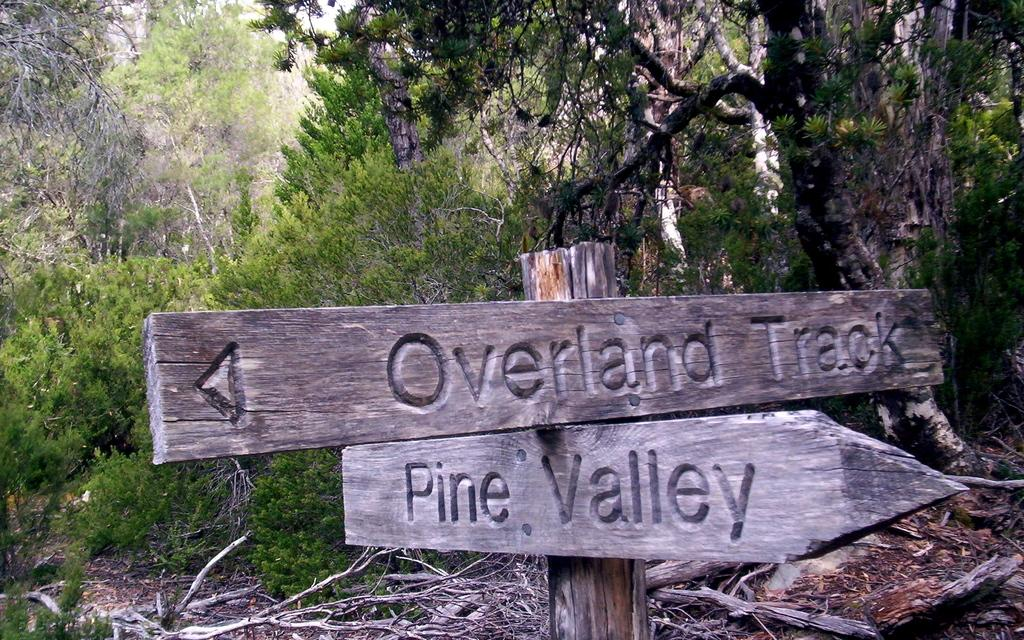What is attached to the wooden pole in the image? There are boards attached to a wooden pole in the image. What can be seen growing from the ground in the image? There are stems in the image. What type of natural environment is visible in the background of the image? There are trees visible in the background of the image. How many boats are present in the image? There are no boats present in the image. What type of produce can be seen growing on the trees in the image? There are no trees with produce visible in the image; only stems are present. 